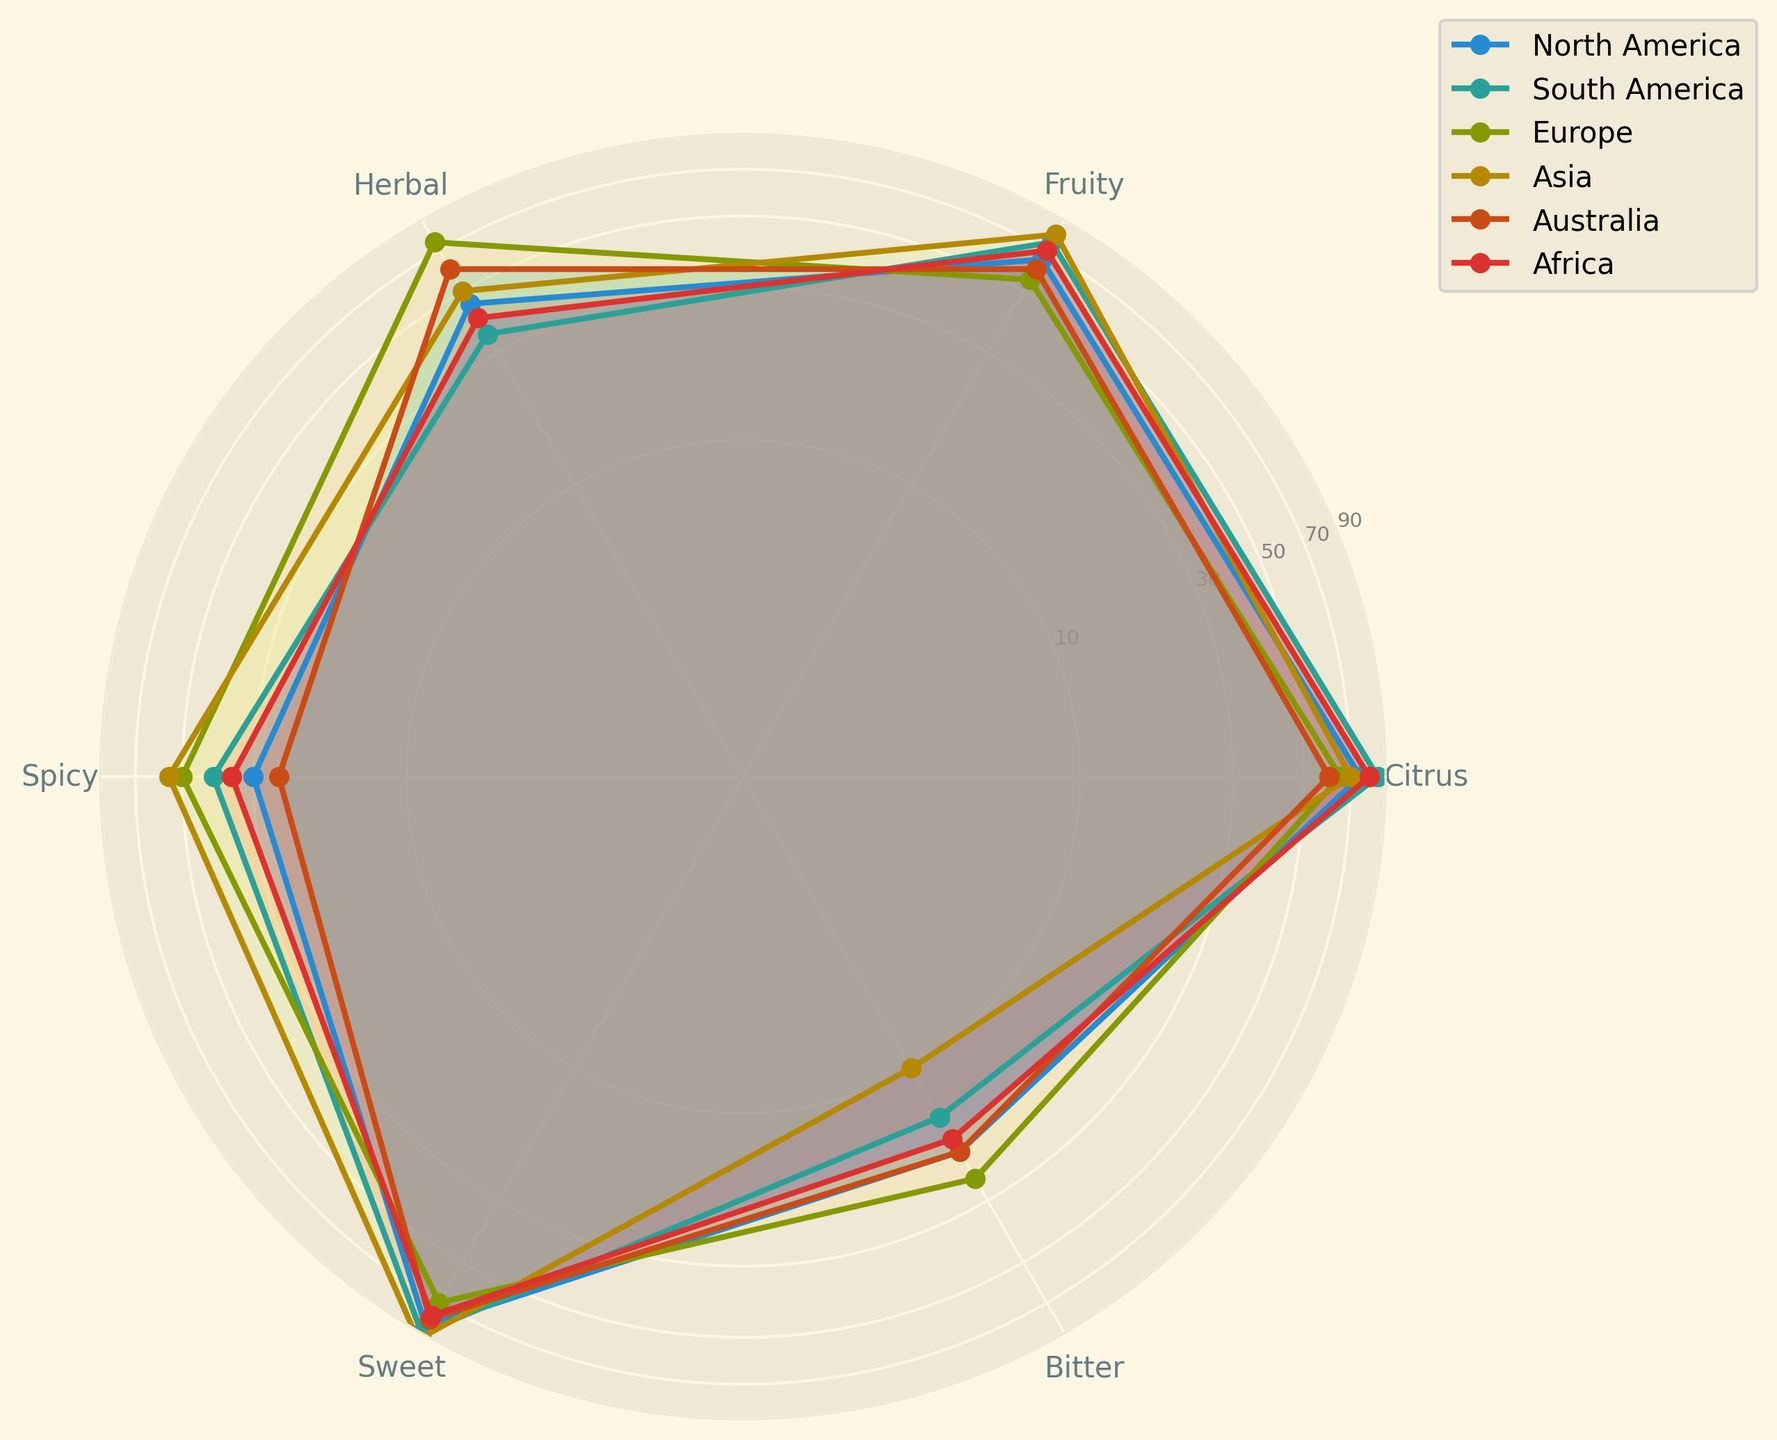What region has the highest preference for Sweet flavors? Compare the values for Sweet flavors across all regions. The highest value is 95 for Asia.
Answer: Asia Which regions have the same preference for Bitter flavors? Look at the Bitter flavor values for all regions to find matches. North America and Australia both have a value of 20.
Answer: North America, Australia What is the average preference for Citrus flavors across all regions? Sum the values for Citrus flavors across all regions and divide by the number of regions: (75 + 85 + 65 + 70 + 60 + 80) / 6
Answer: 72.5 Which region prefers Herbal flavors more than Fruity flavors? Compare the values for Herbal and Fruity flavors in each region. Europe and Australia have higher values for Herbal compared to Fruity.
Answer: Europe, Australia What is the difference in preference for Spicy flavors between South America and Asia? Subtract the value for Spicy flavors in South America from that in Asia: 55 - 40
Answer: 15 Which region has the least preference for Bitter flavors? Compare the values for Bitter flavors across all regions. The lowest value is 10 for Asia.
Answer: Asia Which flavor does North America prefer the least? Identify the minimum value for North America across all flavors. The value is 20 for Bitter.
Answer: Bitter Is the preference for Citrus in North America higher or lower than in South America? Compare the Citrus values for North America (75) and South America (85). North America has a lower value.
Answer: Lower What is the combined preference for Sweet and Fruity flavors in Africa? Sum the values for Sweet and Fruity flavors in Africa: 78 + 70
Answer: 148 Does any region have an equal preference for Citrus and Herbal flavors? Compare the Citrus and Herbal values for each region. Australia has equal values of 60 for both flavors.
Answer: Australia 